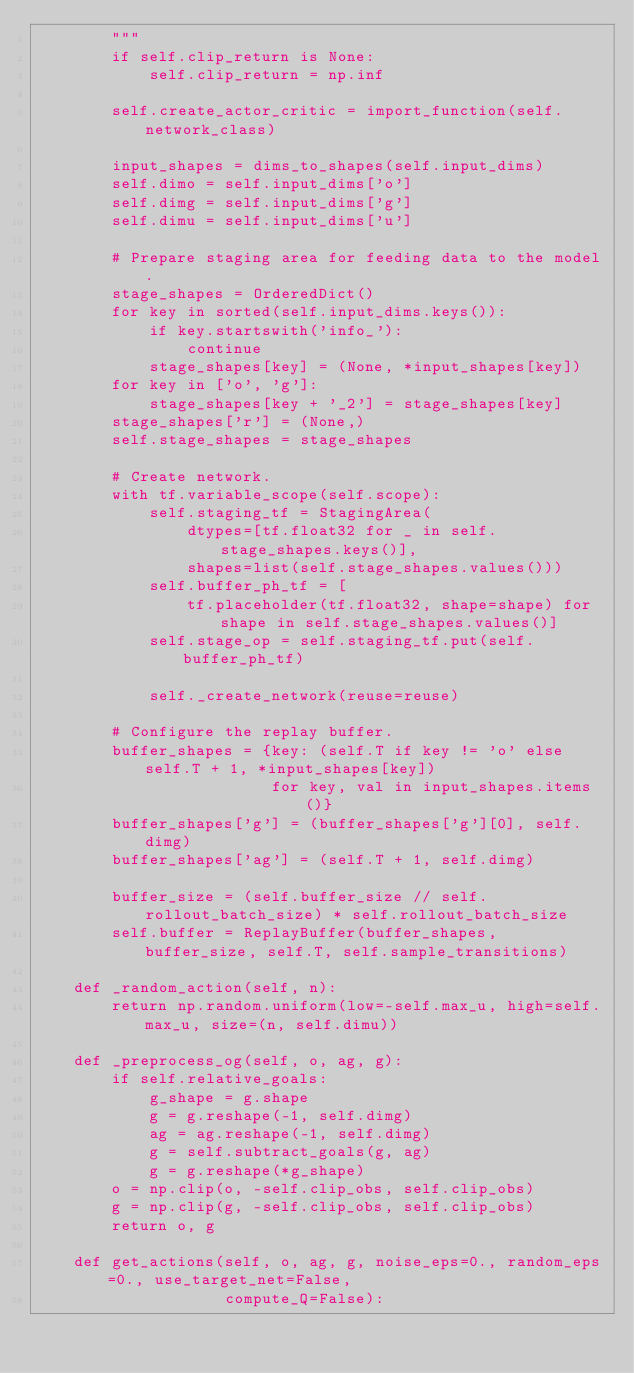Convert code to text. <code><loc_0><loc_0><loc_500><loc_500><_Python_>        """
        if self.clip_return is None:
            self.clip_return = np.inf

        self.create_actor_critic = import_function(self.network_class)

        input_shapes = dims_to_shapes(self.input_dims)
        self.dimo = self.input_dims['o']
        self.dimg = self.input_dims['g']
        self.dimu = self.input_dims['u']

        # Prepare staging area for feeding data to the model.
        stage_shapes = OrderedDict()
        for key in sorted(self.input_dims.keys()):
            if key.startswith('info_'):
                continue
            stage_shapes[key] = (None, *input_shapes[key])
        for key in ['o', 'g']:
            stage_shapes[key + '_2'] = stage_shapes[key]
        stage_shapes['r'] = (None,)
        self.stage_shapes = stage_shapes

        # Create network.
        with tf.variable_scope(self.scope):
            self.staging_tf = StagingArea(
                dtypes=[tf.float32 for _ in self.stage_shapes.keys()],
                shapes=list(self.stage_shapes.values()))
            self.buffer_ph_tf = [
                tf.placeholder(tf.float32, shape=shape) for shape in self.stage_shapes.values()]
            self.stage_op = self.staging_tf.put(self.buffer_ph_tf)

            self._create_network(reuse=reuse)

        # Configure the replay buffer.
        buffer_shapes = {key: (self.T if key != 'o' else self.T + 1, *input_shapes[key])
                         for key, val in input_shapes.items()}
        buffer_shapes['g'] = (buffer_shapes['g'][0], self.dimg)
        buffer_shapes['ag'] = (self.T + 1, self.dimg)

        buffer_size = (self.buffer_size // self.rollout_batch_size) * self.rollout_batch_size
        self.buffer = ReplayBuffer(buffer_shapes, buffer_size, self.T, self.sample_transitions)

    def _random_action(self, n):
        return np.random.uniform(low=-self.max_u, high=self.max_u, size=(n, self.dimu))

    def _preprocess_og(self, o, ag, g):
        if self.relative_goals:
            g_shape = g.shape
            g = g.reshape(-1, self.dimg)
            ag = ag.reshape(-1, self.dimg)
            g = self.subtract_goals(g, ag)
            g = g.reshape(*g_shape)
        o = np.clip(o, -self.clip_obs, self.clip_obs)
        g = np.clip(g, -self.clip_obs, self.clip_obs)
        return o, g

    def get_actions(self, o, ag, g, noise_eps=0., random_eps=0., use_target_net=False,
                    compute_Q=False):</code> 